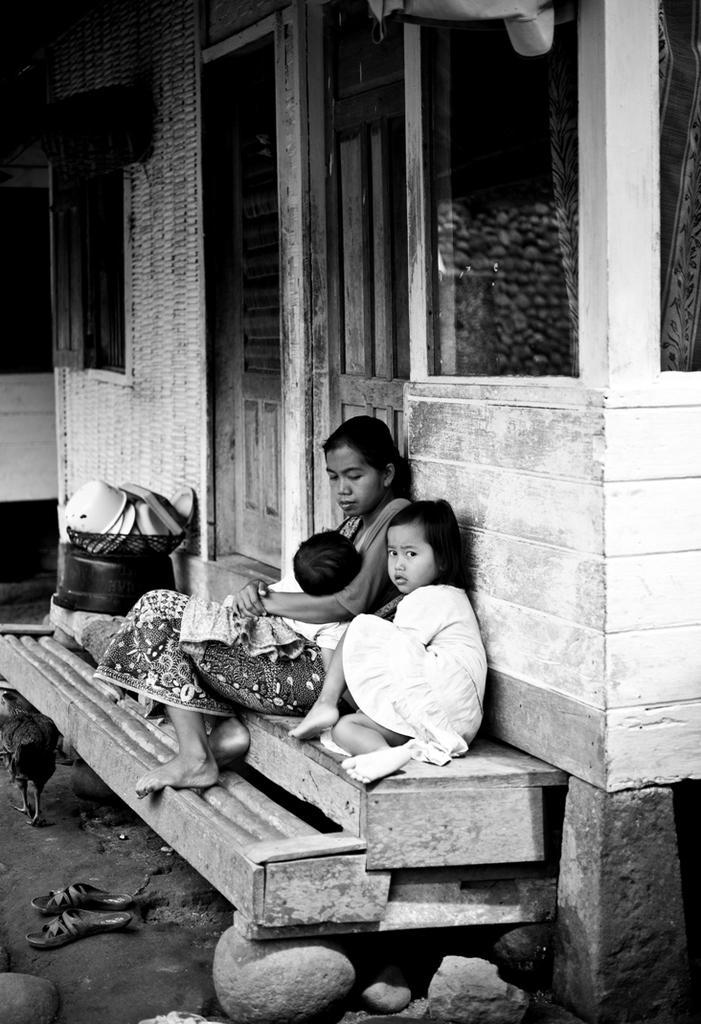Please provide a concise description of this image. In this image I can see the black and white picture in which I can see few persons sitting on the stairs, few rocks, a bird which is black in color, few utensils in the grill and the house. I can see a pair of footwear on the ground. 